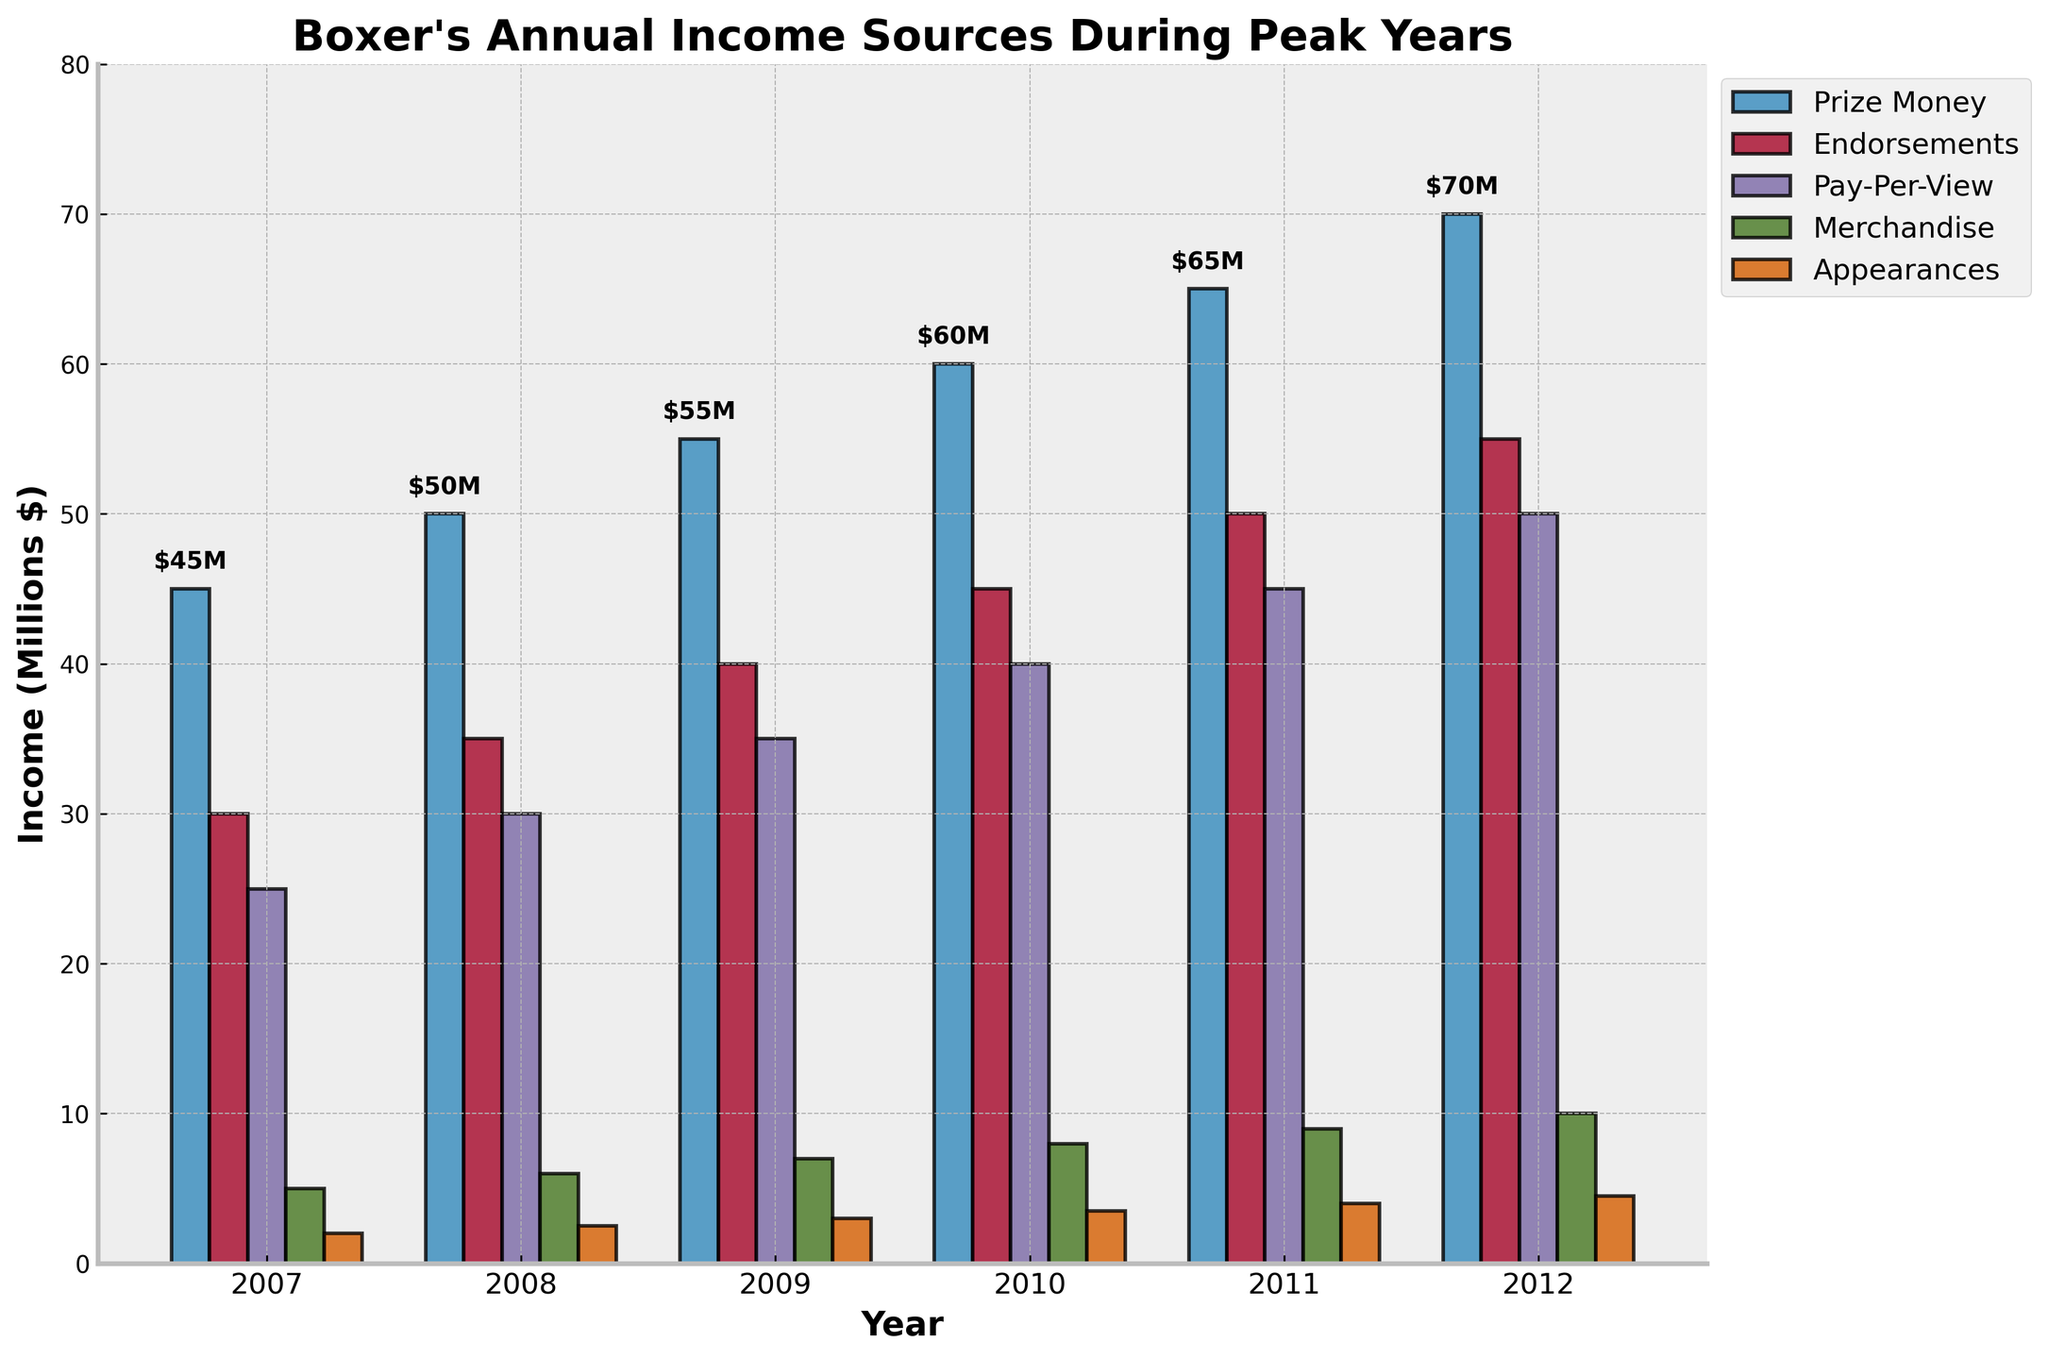Which year had the highest total income? To find the highest total income, sum the different income sources for each year and compare them. The year 2012 has the highest totals: $70M (Prize Money) + $55M (Endorsements) + $50M (Pay-Per-View) + $10M (Merchandise) + $4.5M (Appearances) = $189.5M
Answer: 2012 Which income source increased the most between 2007 and 2012? To determine the income source with the highest increase, subtract the amount in 2007 from the amount in 2012 for each category: Prize Money ($70M - $45M = $25M), Endorsements ($55M - $30M = $25M), Pay-Per-View ($50M - $25M = $25M), Merchandise ($10M - $5M = $5M), Appearances ($4.5M - $2M = $2.5M). The highest increases all equal $25M
Answer: Prize Money, Endorsements, and Pay-Per-View What is the average annual income from Endorsements over the period? Average annual income from Endorsements is calculated by summing the Endorsements from 2007 to 2012 and dividing by the number of years: ($30M + $35M + $40M + $45M + $50M + $55M) / 6 = $42.5M
Answer: $42.5M In which year were the Appearances income the lowest? Visually, the shortest bar in the Appearances category represents the lowest income. The lowest bar in the Appearances category occurs in 2007, which is $2M
Answer: 2007 Which year showed the largest year-over-year increase in total income? Calculate year-over-year increase for each year: from 2007 to 2008 (($91.5M - $80M) = $11.5M), from 2008 to 2009 (($124.5M - $91.5M) = $33M), from 2009 to 2010 (($151.5M - $124.5M) = $27M), from 2010 to 2011 (($180M - $151.5M) = $28.5M), from 2011 to 2012 (($189.5M - $180M) = $9.5M). The largest increase is from 2008 to 2009 by $33M
Answer: 2008 to 2009 What is the total income from Merchandise over the six-year period? Sum the Merchandise income for each year from 2007 to 2012: $5M + $6M + $7M + $8M + $9M + $10M = $45M
Answer: $45M How does Prize Money in 2011 compare to Endorsements in 2009? Compare the values for the two given points: Prize Money in 2011 is $65M and Endorsements in 2009 is $40M. The Prize Money in 2011 is greater
Answer: Prize Money in 2011 is greater What is the relative contribution of Pay-Per-View income in 2010 as a percentage of total income that year? Calculate the relative contribution by dividing Pay-Per-View income by total income for 2010 and multiplying by 100: ($40M / $151.5M) * 100 ≈ 26.4%
Answer: 26.4% Which category showed the most consistent growth over the years? Endorsements showed consistent growth, increasing by $5M every year from 2007 ($30M) to 2012 ($55M) without any fluctuations. Each successive year has a greater income than the previous year by exactly $5M.
Answer: Endorsements 